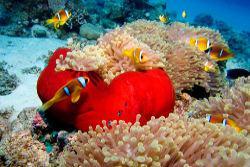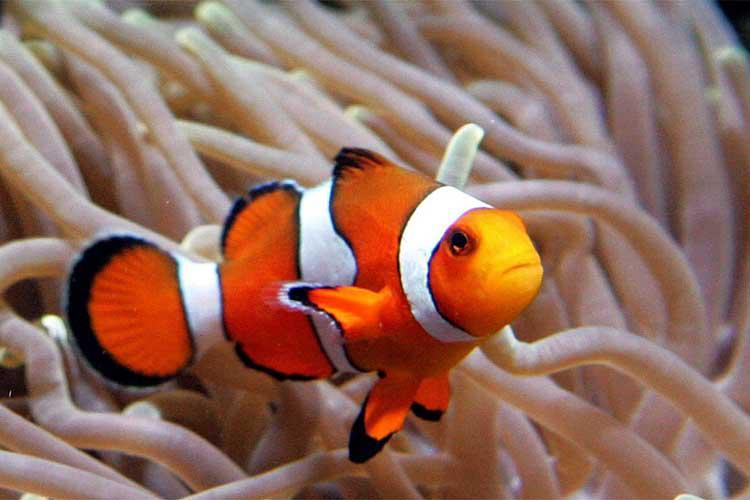The first image is the image on the left, the second image is the image on the right. Analyze the images presented: Is the assertion "Both images show mainly similar-shaped orange-and-white striped fish swimming among anemone tendrils." valid? Answer yes or no. Yes. 